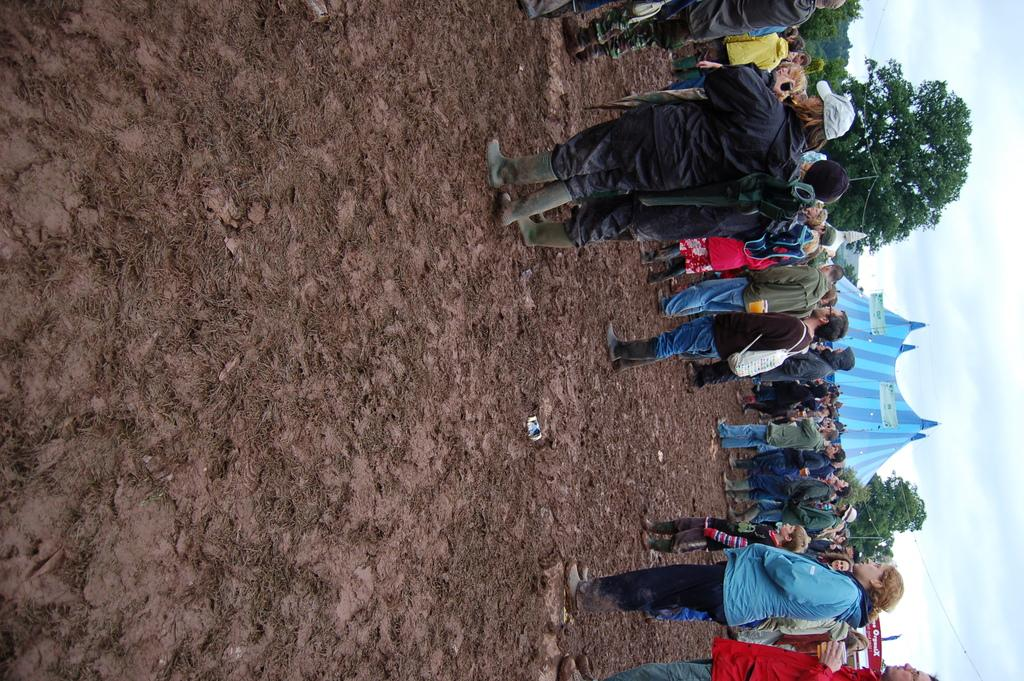What type of terrain is visible in the image? There is sand in the image. Who or what can be seen in the image? There are people in the image. What type of vegetation is present in the image? There are trees in the image. What type of structure is visible in the image? There is a shed in the image. What object can be seen in the image that might be used for displaying information or messages? There is a board in the image. What can be seen in the background of the image? The sky is visible in the background of the image. Where is the kettle located in the image? There is no kettle present in the image. What type of emotion can be seen on the people's faces in the image? The image does not show the people's faces, so it is not possible to determine their emotions. 